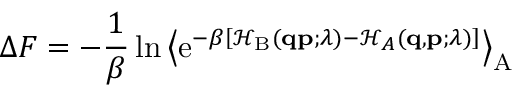Convert formula to latex. <formula><loc_0><loc_0><loc_500><loc_500>\Delta F = - \frac { 1 } { \beta } \ln \left \langle e ^ { - \beta \left [ \mathcal { H } _ { B } ( q p ; \lambda ) - \mathcal { H } _ { A } ( q , p ; \lambda ) \right ] } \right \rangle _ { A }</formula> 